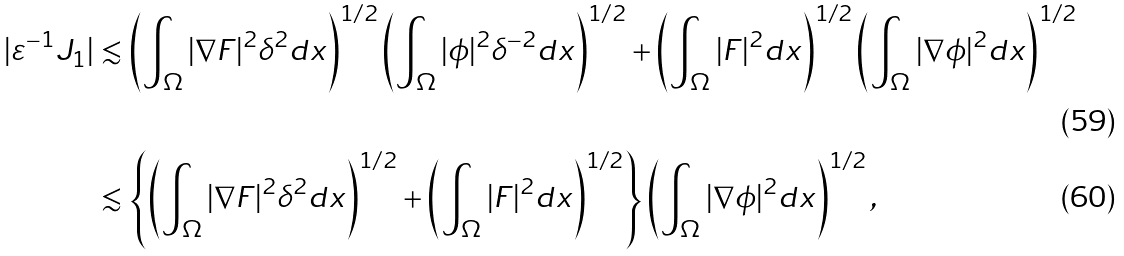Convert formula to latex. <formula><loc_0><loc_0><loc_500><loc_500>| \varepsilon ^ { - 1 } J _ { 1 } | & \lesssim \left ( \int _ { \Omega } | \nabla F | ^ { 2 } \delta ^ { 2 } d x \right ) ^ { 1 / 2 } \left ( \int _ { \Omega } | \phi | ^ { 2 } \delta ^ { - 2 } d x \right ) ^ { 1 / 2 } + \left ( \int _ { \Omega } | F | ^ { 2 } d x \right ) ^ { 1 / 2 } \left ( \int _ { \Omega } | \nabla \phi | ^ { 2 } d x \right ) ^ { 1 / 2 } \\ & \lesssim \left \{ \left ( \int _ { \Omega } | \nabla F | ^ { 2 } \delta ^ { 2 } d x \right ) ^ { 1 / 2 } + \left ( \int _ { \Omega } | F | ^ { 2 } d x \right ) ^ { 1 / 2 } \right \} \left ( \int _ { \Omega } | \nabla \phi | ^ { 2 } d x \right ) ^ { 1 / 2 } ,</formula> 